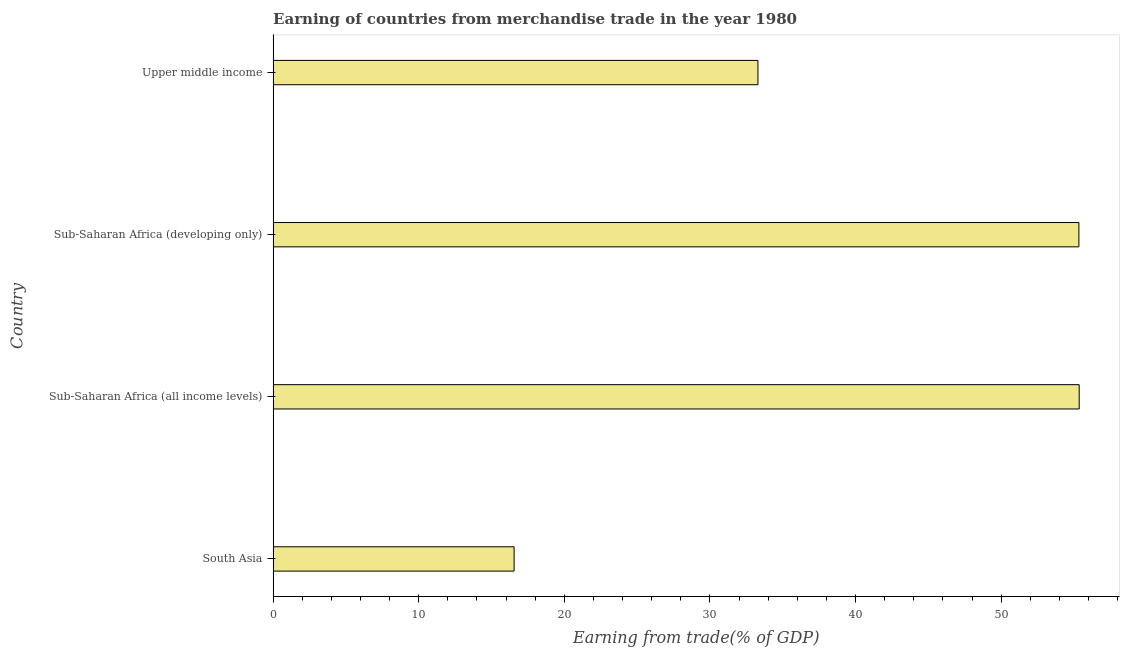What is the title of the graph?
Provide a short and direct response. Earning of countries from merchandise trade in the year 1980. What is the label or title of the X-axis?
Provide a succinct answer. Earning from trade(% of GDP). What is the earning from merchandise trade in Sub-Saharan Africa (all income levels)?
Your response must be concise. 55.35. Across all countries, what is the maximum earning from merchandise trade?
Ensure brevity in your answer.  55.35. Across all countries, what is the minimum earning from merchandise trade?
Keep it short and to the point. 16.55. In which country was the earning from merchandise trade maximum?
Make the answer very short. Sub-Saharan Africa (all income levels). In which country was the earning from merchandise trade minimum?
Provide a short and direct response. South Asia. What is the sum of the earning from merchandise trade?
Keep it short and to the point. 160.53. What is the difference between the earning from merchandise trade in South Asia and Sub-Saharan Africa (developing only)?
Make the answer very short. -38.78. What is the average earning from merchandise trade per country?
Your response must be concise. 40.13. What is the median earning from merchandise trade?
Your answer should be compact. 44.31. What is the ratio of the earning from merchandise trade in Sub-Saharan Africa (developing only) to that in Upper middle income?
Keep it short and to the point. 1.66. Is the difference between the earning from merchandise trade in Sub-Saharan Africa (developing only) and Upper middle income greater than the difference between any two countries?
Provide a short and direct response. No. What is the difference between the highest and the second highest earning from merchandise trade?
Your answer should be compact. 0.02. What is the difference between the highest and the lowest earning from merchandise trade?
Your answer should be very brief. 38.8. In how many countries, is the earning from merchandise trade greater than the average earning from merchandise trade taken over all countries?
Ensure brevity in your answer.  2. What is the difference between two consecutive major ticks on the X-axis?
Your answer should be very brief. 10. Are the values on the major ticks of X-axis written in scientific E-notation?
Provide a short and direct response. No. What is the Earning from trade(% of GDP) of South Asia?
Ensure brevity in your answer.  16.55. What is the Earning from trade(% of GDP) of Sub-Saharan Africa (all income levels)?
Your answer should be very brief. 55.35. What is the Earning from trade(% of GDP) in Sub-Saharan Africa (developing only)?
Provide a succinct answer. 55.33. What is the Earning from trade(% of GDP) of Upper middle income?
Ensure brevity in your answer.  33.29. What is the difference between the Earning from trade(% of GDP) in South Asia and Sub-Saharan Africa (all income levels)?
Your response must be concise. -38.8. What is the difference between the Earning from trade(% of GDP) in South Asia and Sub-Saharan Africa (developing only)?
Make the answer very short. -38.78. What is the difference between the Earning from trade(% of GDP) in South Asia and Upper middle income?
Offer a terse response. -16.74. What is the difference between the Earning from trade(% of GDP) in Sub-Saharan Africa (all income levels) and Sub-Saharan Africa (developing only)?
Provide a short and direct response. 0.02. What is the difference between the Earning from trade(% of GDP) in Sub-Saharan Africa (all income levels) and Upper middle income?
Your answer should be compact. 22.06. What is the difference between the Earning from trade(% of GDP) in Sub-Saharan Africa (developing only) and Upper middle income?
Ensure brevity in your answer.  22.04. What is the ratio of the Earning from trade(% of GDP) in South Asia to that in Sub-Saharan Africa (all income levels)?
Your answer should be very brief. 0.3. What is the ratio of the Earning from trade(% of GDP) in South Asia to that in Sub-Saharan Africa (developing only)?
Offer a terse response. 0.3. What is the ratio of the Earning from trade(% of GDP) in South Asia to that in Upper middle income?
Provide a succinct answer. 0.5. What is the ratio of the Earning from trade(% of GDP) in Sub-Saharan Africa (all income levels) to that in Sub-Saharan Africa (developing only)?
Provide a succinct answer. 1. What is the ratio of the Earning from trade(% of GDP) in Sub-Saharan Africa (all income levels) to that in Upper middle income?
Offer a terse response. 1.66. What is the ratio of the Earning from trade(% of GDP) in Sub-Saharan Africa (developing only) to that in Upper middle income?
Provide a short and direct response. 1.66. 